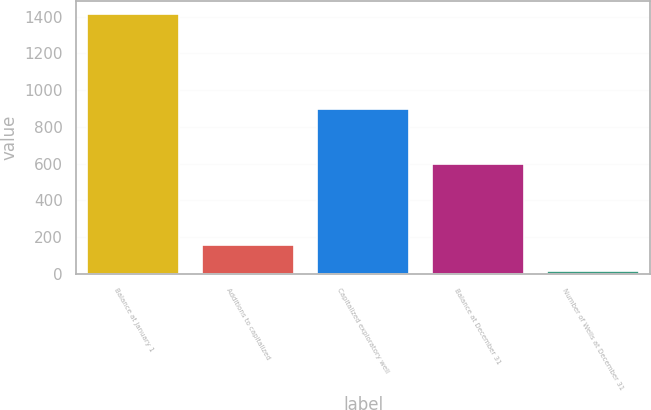Convert chart. <chart><loc_0><loc_0><loc_500><loc_500><bar_chart><fcel>Balance at January 1<fcel>Additions to capitalized<fcel>Capitalized exploratory well<fcel>Balance at December 31<fcel>Number of Wells at December 31<nl><fcel>1415<fcel>156.8<fcel>897<fcel>597<fcel>17<nl></chart> 